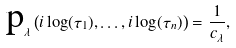<formula> <loc_0><loc_0><loc_500><loc_500>\text {p} _ { \lambda } \left ( i \log ( \tau _ { 1 } ) , \dots , i \log ( \tau _ { n } ) \right ) = \frac { 1 } { c _ { \lambda } } ,</formula> 